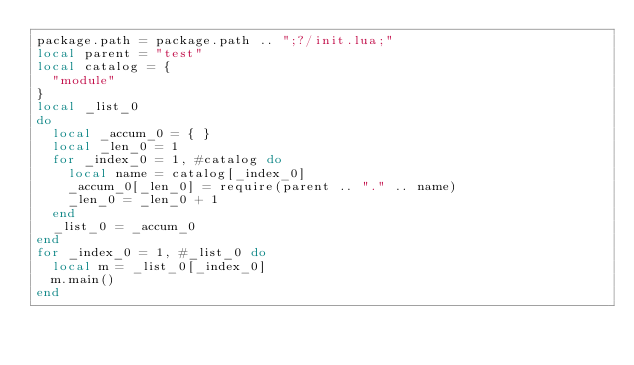Convert code to text. <code><loc_0><loc_0><loc_500><loc_500><_Lua_>package.path = package.path .. ";?/init.lua;"
local parent = "test"
local catalog = {
  "module"
}
local _list_0
do
  local _accum_0 = { }
  local _len_0 = 1
  for _index_0 = 1, #catalog do
    local name = catalog[_index_0]
    _accum_0[_len_0] = require(parent .. "." .. name)
    _len_0 = _len_0 + 1
  end
  _list_0 = _accum_0
end
for _index_0 = 1, #_list_0 do
  local m = _list_0[_index_0]
  m.main()
end
</code> 